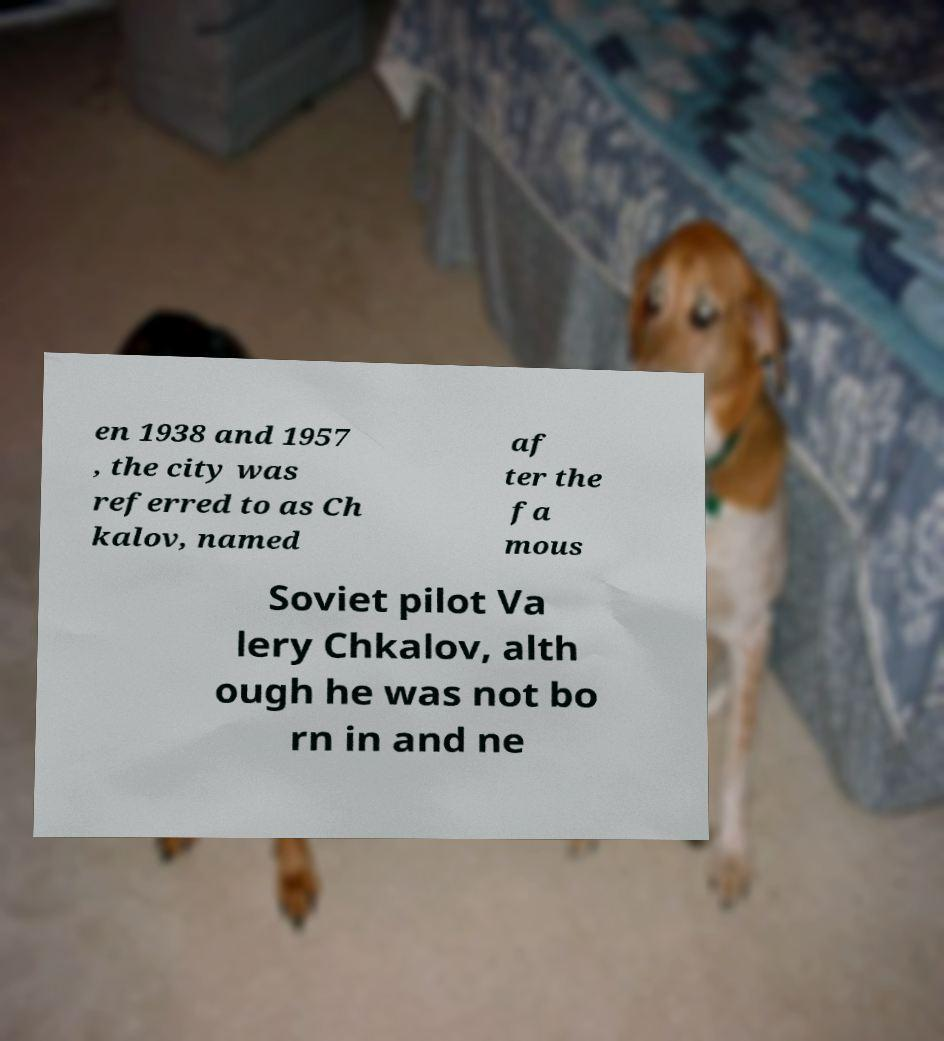Could you extract and type out the text from this image? en 1938 and 1957 , the city was referred to as Ch kalov, named af ter the fa mous Soviet pilot Va lery Chkalov, alth ough he was not bo rn in and ne 